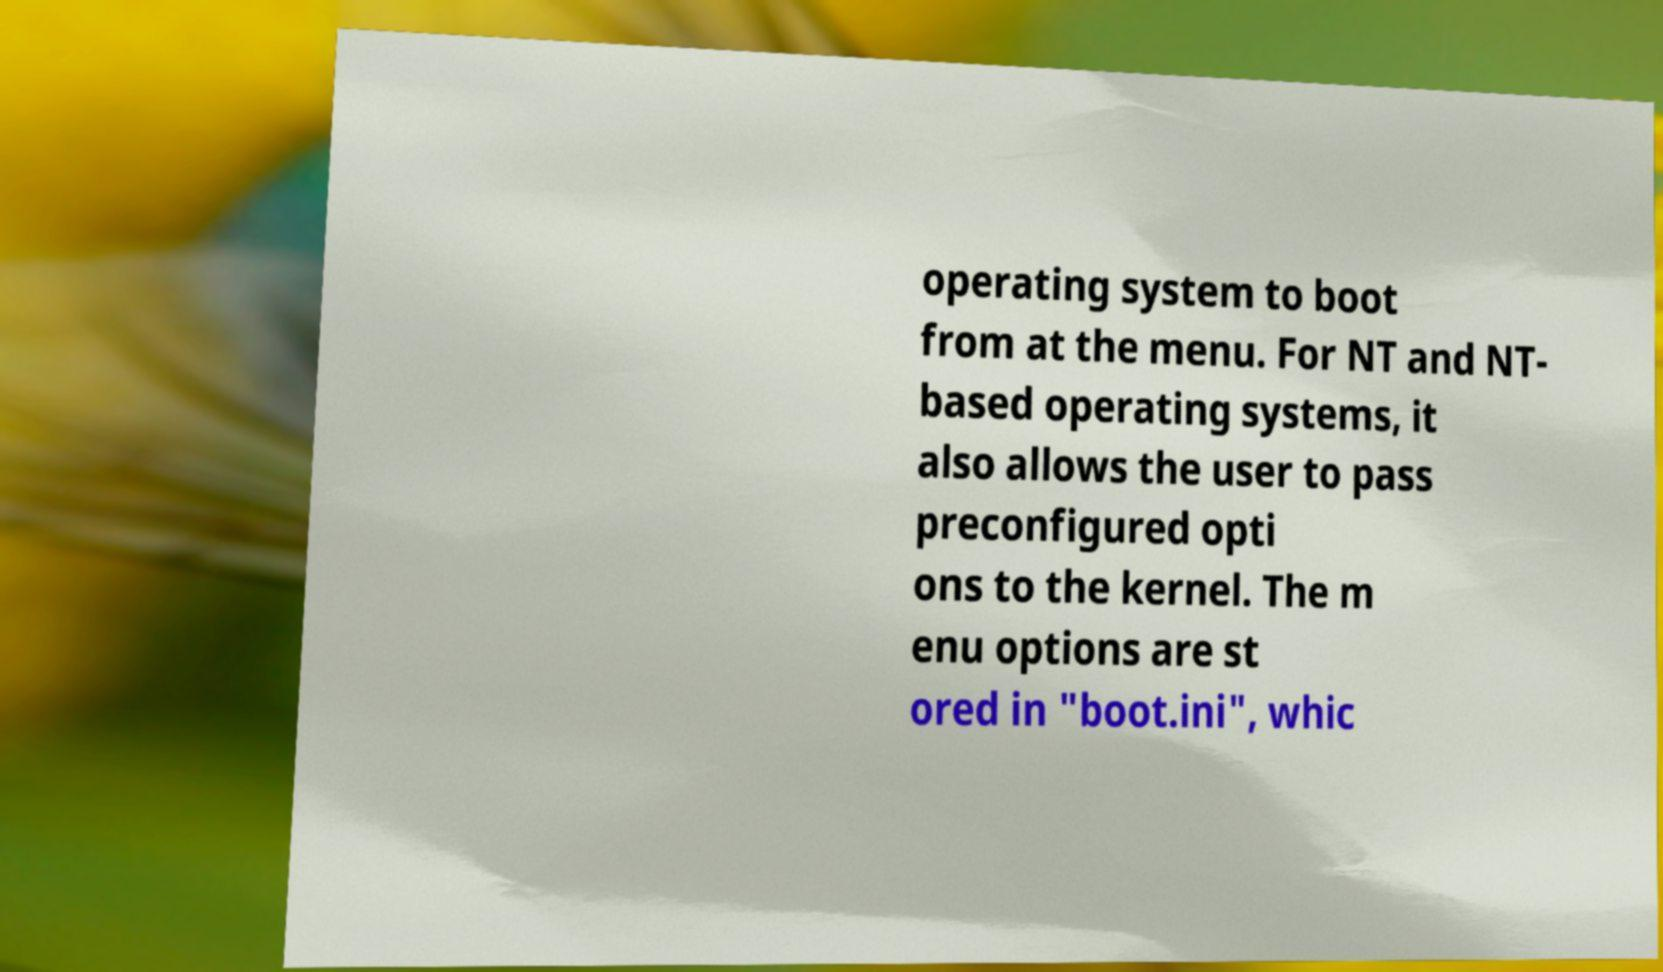Could you assist in decoding the text presented in this image and type it out clearly? operating system to boot from at the menu. For NT and NT- based operating systems, it also allows the user to pass preconfigured opti ons to the kernel. The m enu options are st ored in "boot.ini", whic 